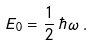Convert formula to latex. <formula><loc_0><loc_0><loc_500><loc_500>E _ { 0 } = \frac { 1 } { 2 } \, \hbar { \, } \omega \, .</formula> 